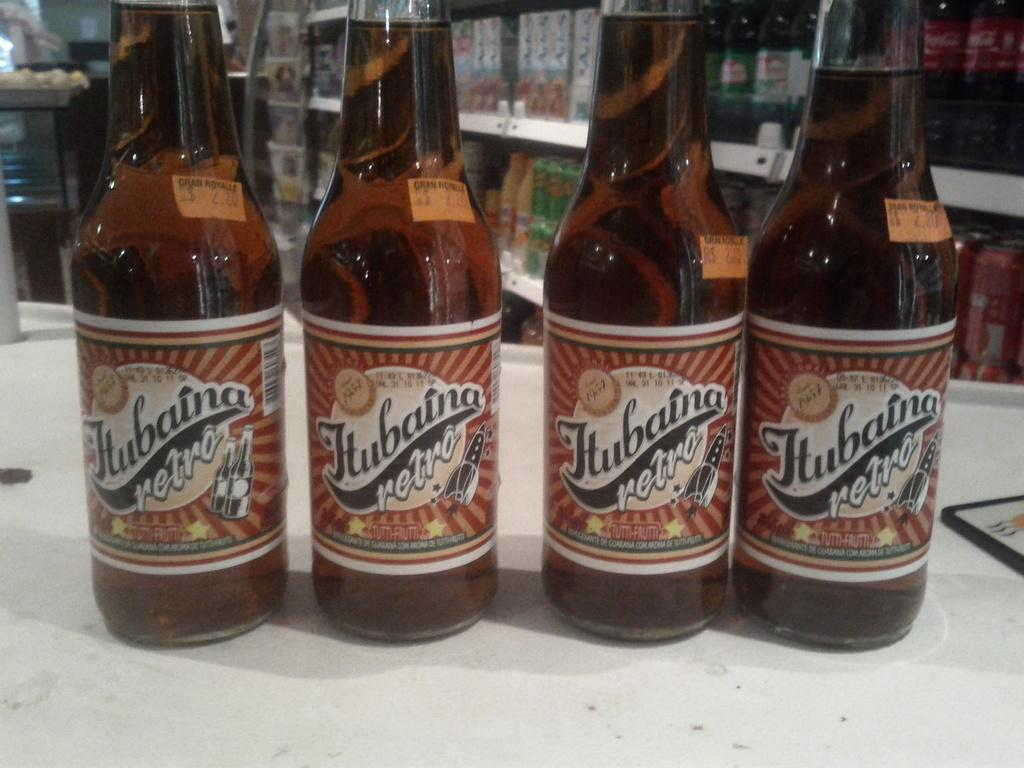<image>
Render a clear and concise summary of the photo. four bottles of hubaina retro tutti-fruitti flavor on a counter top 